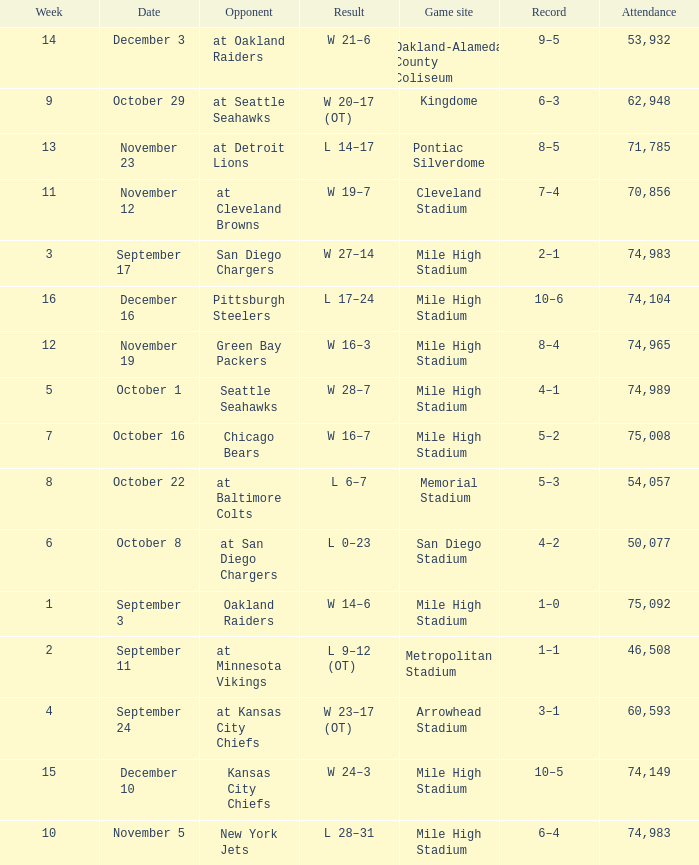Parse the table in full. {'header': ['Week', 'Date', 'Opponent', 'Result', 'Game site', 'Record', 'Attendance'], 'rows': [['14', 'December 3', 'at Oakland Raiders', 'W 21–6', 'Oakland-Alameda County Coliseum', '9–5', '53,932'], ['9', 'October 29', 'at Seattle Seahawks', 'W 20–17 (OT)', 'Kingdome', '6–3', '62,948'], ['13', 'November 23', 'at Detroit Lions', 'L 14–17', 'Pontiac Silverdome', '8–5', '71,785'], ['11', 'November 12', 'at Cleveland Browns', 'W 19–7', 'Cleveland Stadium', '7–4', '70,856'], ['3', 'September 17', 'San Diego Chargers', 'W 27–14', 'Mile High Stadium', '2–1', '74,983'], ['16', 'December 16', 'Pittsburgh Steelers', 'L 17–24', 'Mile High Stadium', '10–6', '74,104'], ['12', 'November 19', 'Green Bay Packers', 'W 16–3', 'Mile High Stadium', '8–4', '74,965'], ['5', 'October 1', 'Seattle Seahawks', 'W 28–7', 'Mile High Stadium', '4–1', '74,989'], ['7', 'October 16', 'Chicago Bears', 'W 16–7', 'Mile High Stadium', '5–2', '75,008'], ['8', 'October 22', 'at Baltimore Colts', 'L 6–7', 'Memorial Stadium', '5–3', '54,057'], ['6', 'October 8', 'at San Diego Chargers', 'L 0–23', 'San Diego Stadium', '4–2', '50,077'], ['1', 'September 3', 'Oakland Raiders', 'W 14–6', 'Mile High Stadium', '1–0', '75,092'], ['2', 'September 11', 'at Minnesota Vikings', 'L 9–12 (OT)', 'Metropolitan Stadium', '1–1', '46,508'], ['4', 'September 24', 'at Kansas City Chiefs', 'W 23–17 (OT)', 'Arrowhead Stadium', '3–1', '60,593'], ['15', 'December 10', 'Kansas City Chiefs', 'W 24–3', 'Mile High Stadium', '10–5', '74,149'], ['10', 'November 5', 'New York Jets', 'L 28–31', 'Mile High Stadium', '6–4', '74,983']]} Which week has a record of 5–2? 7.0. 